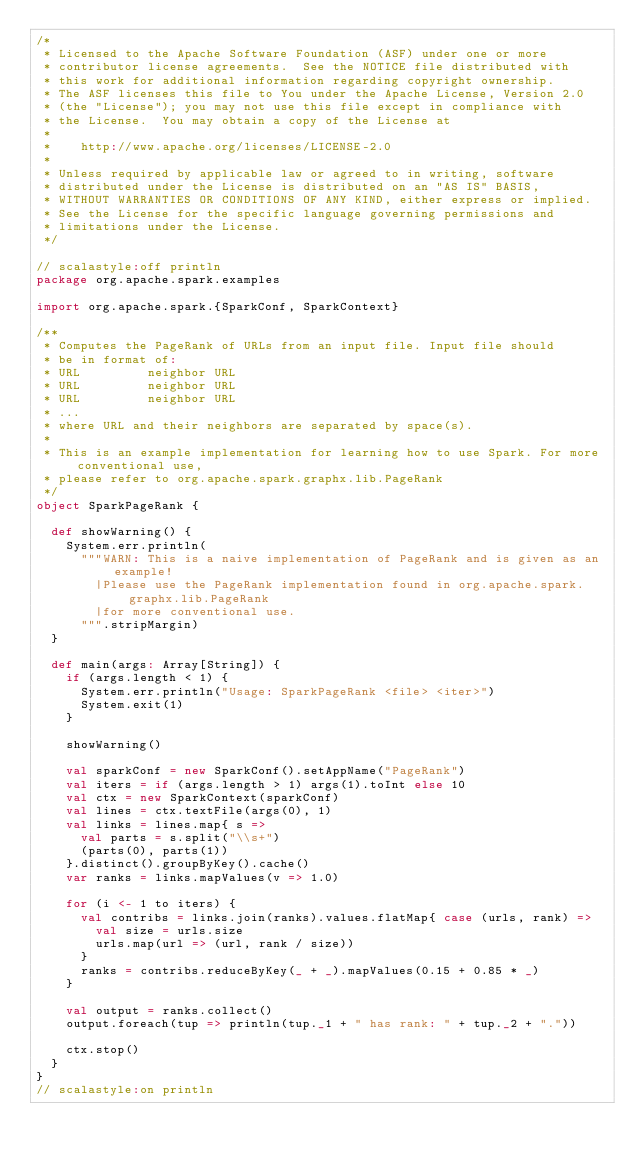<code> <loc_0><loc_0><loc_500><loc_500><_Scala_>/*
 * Licensed to the Apache Software Foundation (ASF) under one or more
 * contributor license agreements.  See the NOTICE file distributed with
 * this work for additional information regarding copyright ownership.
 * The ASF licenses this file to You under the Apache License, Version 2.0
 * (the "License"); you may not use this file except in compliance with
 * the License.  You may obtain a copy of the License at
 *
 *    http://www.apache.org/licenses/LICENSE-2.0
 *
 * Unless required by applicable law or agreed to in writing, software
 * distributed under the License is distributed on an "AS IS" BASIS,
 * WITHOUT WARRANTIES OR CONDITIONS OF ANY KIND, either express or implied.
 * See the License for the specific language governing permissions and
 * limitations under the License.
 */

// scalastyle:off println
package org.apache.spark.examples

import org.apache.spark.{SparkConf, SparkContext}

/**
 * Computes the PageRank of URLs from an input file. Input file should
 * be in format of:
 * URL         neighbor URL
 * URL         neighbor URL
 * URL         neighbor URL
 * ...
 * where URL and their neighbors are separated by space(s).
 *
 * This is an example implementation for learning how to use Spark. For more conventional use,
 * please refer to org.apache.spark.graphx.lib.PageRank
 */
object SparkPageRank {

  def showWarning() {
    System.err.println(
      """WARN: This is a naive implementation of PageRank and is given as an example!
        |Please use the PageRank implementation found in org.apache.spark.graphx.lib.PageRank
        |for more conventional use.
      """.stripMargin)
  }

  def main(args: Array[String]) {
    if (args.length < 1) {
      System.err.println("Usage: SparkPageRank <file> <iter>")
      System.exit(1)
    }

    showWarning()

    val sparkConf = new SparkConf().setAppName("PageRank")
    val iters = if (args.length > 1) args(1).toInt else 10
    val ctx = new SparkContext(sparkConf)
    val lines = ctx.textFile(args(0), 1)
    val links = lines.map{ s =>
      val parts = s.split("\\s+")
      (parts(0), parts(1))
    }.distinct().groupByKey().cache()
    var ranks = links.mapValues(v => 1.0)

    for (i <- 1 to iters) {
      val contribs = links.join(ranks).values.flatMap{ case (urls, rank) =>
        val size = urls.size
        urls.map(url => (url, rank / size))
      }
      ranks = contribs.reduceByKey(_ + _).mapValues(0.15 + 0.85 * _)
    }

    val output = ranks.collect()
    output.foreach(tup => println(tup._1 + " has rank: " + tup._2 + "."))

    ctx.stop()
  }
}
// scalastyle:on println
</code> 